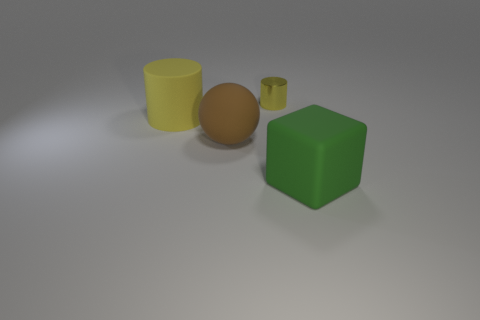Add 2 yellow metallic cylinders. How many objects exist? 6 Subtract all cubes. How many objects are left? 3 Subtract all big blocks. Subtract all large yellow rubber cylinders. How many objects are left? 2 Add 3 large green matte things. How many large green matte things are left? 4 Add 1 cyan matte cylinders. How many cyan matte cylinders exist? 1 Subtract 0 purple blocks. How many objects are left? 4 